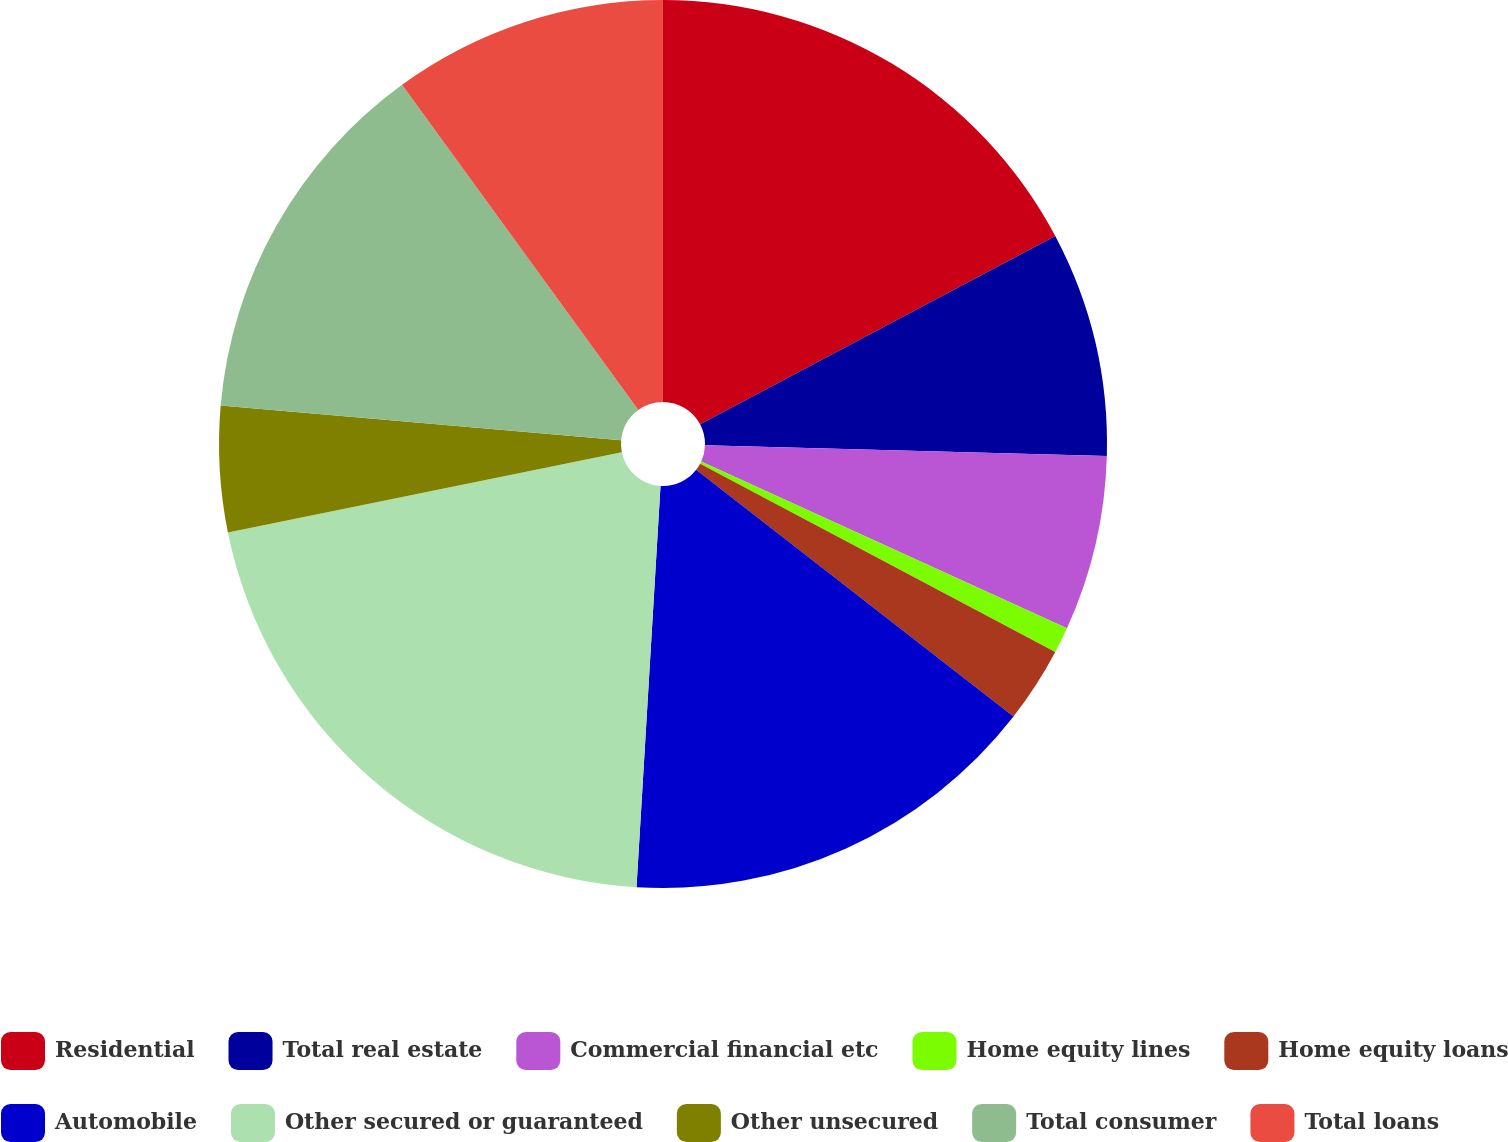Convert chart to OTSL. <chart><loc_0><loc_0><loc_500><loc_500><pie_chart><fcel>Residential<fcel>Total real estate<fcel>Commercial financial etc<fcel>Home equity lines<fcel>Home equity loans<fcel>Automobile<fcel>Other secured or guaranteed<fcel>Other unsecured<fcel>Total consumer<fcel>Total loans<nl><fcel>17.24%<fcel>8.19%<fcel>6.38%<fcel>0.95%<fcel>2.76%<fcel>15.43%<fcel>20.86%<fcel>4.57%<fcel>13.62%<fcel>10.0%<nl></chart> 